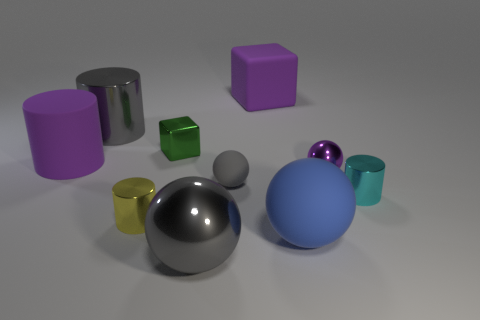Which object seems to reflect the most light and why might that be? The object that appears to reflect the most light is the darkish gray sphere in the centre. Its high-gloss surface creates clear reflections, indicating it has a very smooth material, possibly metallic, which reflects light more efficiently than the matte or less smooth surfaces nearby. 